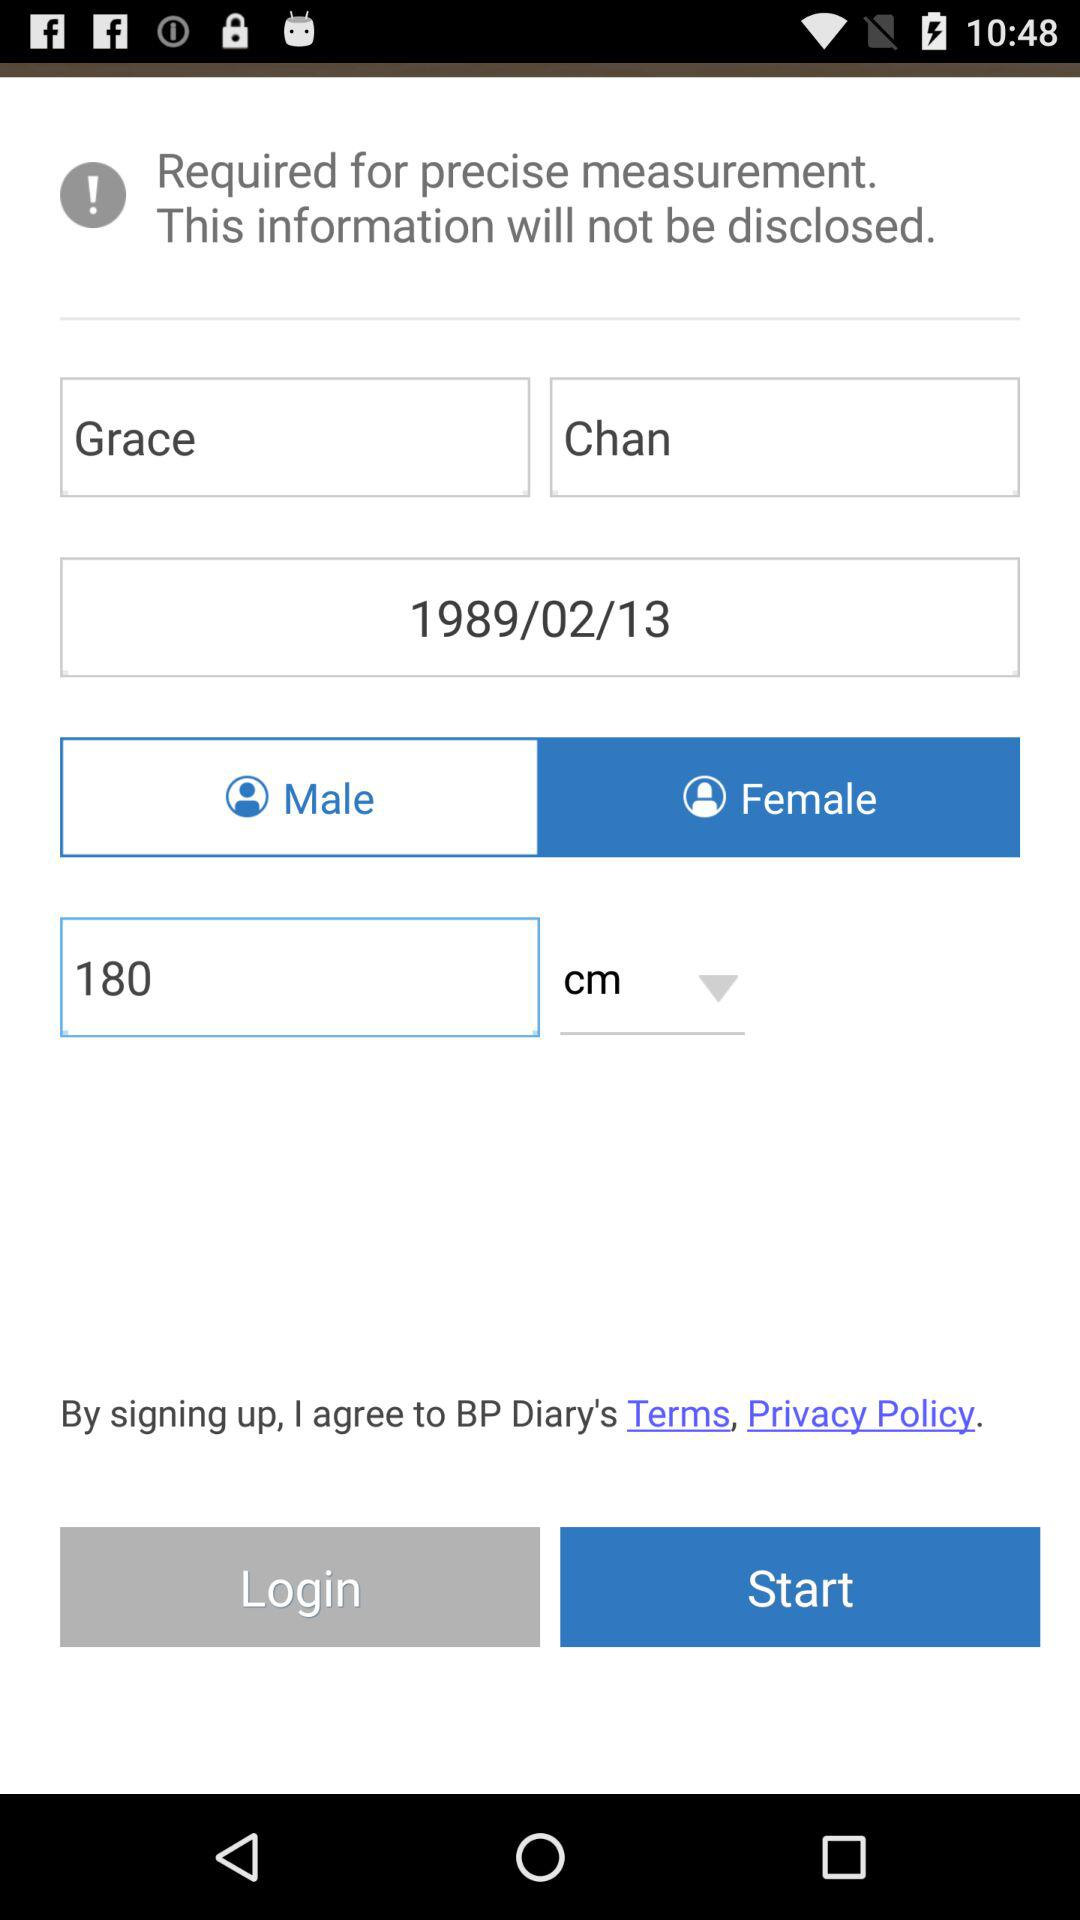What is the height in cm? The height is 180 cm. 